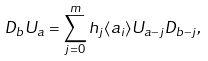Convert formula to latex. <formula><loc_0><loc_0><loc_500><loc_500>D _ { b } U _ { a } = \sum _ { j = 0 } ^ { m } h _ { j } \langle a _ { i } \rangle U _ { a - j } D _ { b - j } ,</formula> 